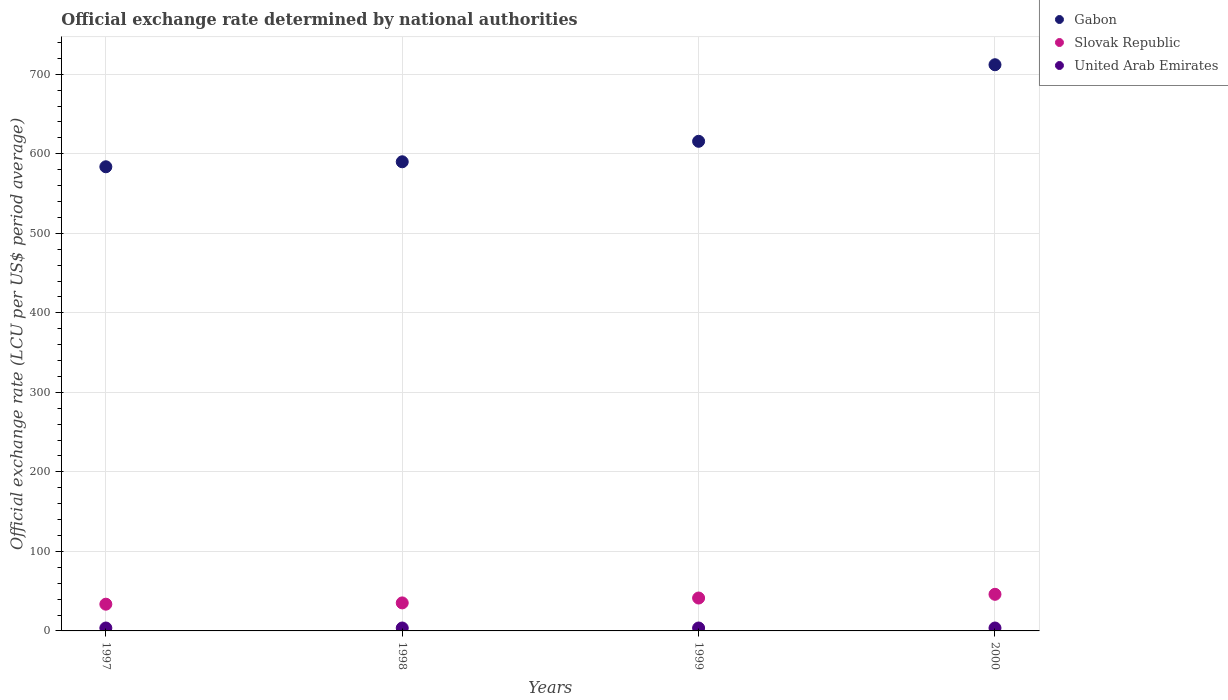How many different coloured dotlines are there?
Make the answer very short. 3. What is the official exchange rate in Slovak Republic in 1997?
Keep it short and to the point. 33.62. Across all years, what is the maximum official exchange rate in United Arab Emirates?
Your answer should be compact. 3.67. Across all years, what is the minimum official exchange rate in United Arab Emirates?
Your answer should be compact. 3.67. What is the total official exchange rate in Gabon in the graph?
Make the answer very short. 2501.3. What is the difference between the official exchange rate in Gabon in 1997 and that in 2000?
Provide a succinct answer. -128.31. What is the difference between the official exchange rate in United Arab Emirates in 1998 and the official exchange rate in Slovak Republic in 1997?
Your response must be concise. -29.94. What is the average official exchange rate in United Arab Emirates per year?
Ensure brevity in your answer.  3.67. In the year 2000, what is the difference between the official exchange rate in Gabon and official exchange rate in United Arab Emirates?
Give a very brief answer. 708.3. In how many years, is the official exchange rate in Gabon greater than 520 LCU?
Keep it short and to the point. 4. What is the ratio of the official exchange rate in Slovak Republic in 1997 to that in 1998?
Provide a short and direct response. 0.95. Is the official exchange rate in United Arab Emirates in 1997 less than that in 1999?
Provide a succinct answer. Yes. What is the difference between the highest and the lowest official exchange rate in Gabon?
Give a very brief answer. 128.31. Is it the case that in every year, the sum of the official exchange rate in United Arab Emirates and official exchange rate in Gabon  is greater than the official exchange rate in Slovak Republic?
Offer a terse response. Yes. Does the official exchange rate in Gabon monotonically increase over the years?
Provide a short and direct response. Yes. What is the difference between two consecutive major ticks on the Y-axis?
Offer a terse response. 100. Are the values on the major ticks of Y-axis written in scientific E-notation?
Keep it short and to the point. No. Does the graph contain grids?
Give a very brief answer. Yes. How many legend labels are there?
Provide a short and direct response. 3. What is the title of the graph?
Keep it short and to the point. Official exchange rate determined by national authorities. What is the label or title of the Y-axis?
Offer a terse response. Official exchange rate (LCU per US$ period average). What is the Official exchange rate (LCU per US$ period average) of Gabon in 1997?
Keep it short and to the point. 583.67. What is the Official exchange rate (LCU per US$ period average) of Slovak Republic in 1997?
Ensure brevity in your answer.  33.62. What is the Official exchange rate (LCU per US$ period average) in United Arab Emirates in 1997?
Keep it short and to the point. 3.67. What is the Official exchange rate (LCU per US$ period average) of Gabon in 1998?
Offer a very short reply. 589.95. What is the Official exchange rate (LCU per US$ period average) of Slovak Republic in 1998?
Offer a terse response. 35.23. What is the Official exchange rate (LCU per US$ period average) in United Arab Emirates in 1998?
Your answer should be very brief. 3.67. What is the Official exchange rate (LCU per US$ period average) in Gabon in 1999?
Make the answer very short. 615.7. What is the Official exchange rate (LCU per US$ period average) of Slovak Republic in 1999?
Keep it short and to the point. 41.36. What is the Official exchange rate (LCU per US$ period average) of United Arab Emirates in 1999?
Offer a terse response. 3.67. What is the Official exchange rate (LCU per US$ period average) in Gabon in 2000?
Your answer should be very brief. 711.98. What is the Official exchange rate (LCU per US$ period average) in Slovak Republic in 2000?
Provide a short and direct response. 46.04. What is the Official exchange rate (LCU per US$ period average) of United Arab Emirates in 2000?
Keep it short and to the point. 3.67. Across all years, what is the maximum Official exchange rate (LCU per US$ period average) of Gabon?
Your answer should be very brief. 711.98. Across all years, what is the maximum Official exchange rate (LCU per US$ period average) of Slovak Republic?
Provide a short and direct response. 46.04. Across all years, what is the maximum Official exchange rate (LCU per US$ period average) of United Arab Emirates?
Keep it short and to the point. 3.67. Across all years, what is the minimum Official exchange rate (LCU per US$ period average) in Gabon?
Make the answer very short. 583.67. Across all years, what is the minimum Official exchange rate (LCU per US$ period average) of Slovak Republic?
Ensure brevity in your answer.  33.62. Across all years, what is the minimum Official exchange rate (LCU per US$ period average) of United Arab Emirates?
Your answer should be compact. 3.67. What is the total Official exchange rate (LCU per US$ period average) of Gabon in the graph?
Provide a succinct answer. 2501.3. What is the total Official exchange rate (LCU per US$ period average) of Slovak Republic in the graph?
Give a very brief answer. 156.25. What is the total Official exchange rate (LCU per US$ period average) of United Arab Emirates in the graph?
Give a very brief answer. 14.69. What is the difference between the Official exchange rate (LCU per US$ period average) in Gabon in 1997 and that in 1998?
Offer a very short reply. -6.28. What is the difference between the Official exchange rate (LCU per US$ period average) of Slovak Republic in 1997 and that in 1998?
Offer a very short reply. -1.62. What is the difference between the Official exchange rate (LCU per US$ period average) of United Arab Emirates in 1997 and that in 1998?
Provide a succinct answer. -0. What is the difference between the Official exchange rate (LCU per US$ period average) in Gabon in 1997 and that in 1999?
Provide a succinct answer. -32.03. What is the difference between the Official exchange rate (LCU per US$ period average) of Slovak Republic in 1997 and that in 1999?
Your answer should be very brief. -7.75. What is the difference between the Official exchange rate (LCU per US$ period average) in United Arab Emirates in 1997 and that in 1999?
Give a very brief answer. -0. What is the difference between the Official exchange rate (LCU per US$ period average) in Gabon in 1997 and that in 2000?
Make the answer very short. -128.31. What is the difference between the Official exchange rate (LCU per US$ period average) of Slovak Republic in 1997 and that in 2000?
Provide a short and direct response. -12.42. What is the difference between the Official exchange rate (LCU per US$ period average) of United Arab Emirates in 1997 and that in 2000?
Make the answer very short. -0. What is the difference between the Official exchange rate (LCU per US$ period average) of Gabon in 1998 and that in 1999?
Give a very brief answer. -25.75. What is the difference between the Official exchange rate (LCU per US$ period average) of Slovak Republic in 1998 and that in 1999?
Keep it short and to the point. -6.13. What is the difference between the Official exchange rate (LCU per US$ period average) of Gabon in 1998 and that in 2000?
Give a very brief answer. -122.02. What is the difference between the Official exchange rate (LCU per US$ period average) of Slovak Republic in 1998 and that in 2000?
Provide a succinct answer. -10.8. What is the difference between the Official exchange rate (LCU per US$ period average) in United Arab Emirates in 1998 and that in 2000?
Provide a succinct answer. 0. What is the difference between the Official exchange rate (LCU per US$ period average) of Gabon in 1999 and that in 2000?
Provide a succinct answer. -96.28. What is the difference between the Official exchange rate (LCU per US$ period average) in Slovak Republic in 1999 and that in 2000?
Your response must be concise. -4.67. What is the difference between the Official exchange rate (LCU per US$ period average) of United Arab Emirates in 1999 and that in 2000?
Ensure brevity in your answer.  0. What is the difference between the Official exchange rate (LCU per US$ period average) of Gabon in 1997 and the Official exchange rate (LCU per US$ period average) of Slovak Republic in 1998?
Offer a terse response. 548.44. What is the difference between the Official exchange rate (LCU per US$ period average) of Gabon in 1997 and the Official exchange rate (LCU per US$ period average) of United Arab Emirates in 1998?
Your response must be concise. 580. What is the difference between the Official exchange rate (LCU per US$ period average) of Slovak Republic in 1997 and the Official exchange rate (LCU per US$ period average) of United Arab Emirates in 1998?
Provide a succinct answer. 29.94. What is the difference between the Official exchange rate (LCU per US$ period average) of Gabon in 1997 and the Official exchange rate (LCU per US$ period average) of Slovak Republic in 1999?
Provide a succinct answer. 542.31. What is the difference between the Official exchange rate (LCU per US$ period average) in Gabon in 1997 and the Official exchange rate (LCU per US$ period average) in United Arab Emirates in 1999?
Your answer should be very brief. 580. What is the difference between the Official exchange rate (LCU per US$ period average) of Slovak Republic in 1997 and the Official exchange rate (LCU per US$ period average) of United Arab Emirates in 1999?
Provide a short and direct response. 29.94. What is the difference between the Official exchange rate (LCU per US$ period average) of Gabon in 1997 and the Official exchange rate (LCU per US$ period average) of Slovak Republic in 2000?
Give a very brief answer. 537.63. What is the difference between the Official exchange rate (LCU per US$ period average) in Gabon in 1997 and the Official exchange rate (LCU per US$ period average) in United Arab Emirates in 2000?
Keep it short and to the point. 580. What is the difference between the Official exchange rate (LCU per US$ period average) of Slovak Republic in 1997 and the Official exchange rate (LCU per US$ period average) of United Arab Emirates in 2000?
Your answer should be very brief. 29.94. What is the difference between the Official exchange rate (LCU per US$ period average) in Gabon in 1998 and the Official exchange rate (LCU per US$ period average) in Slovak Republic in 1999?
Offer a terse response. 548.59. What is the difference between the Official exchange rate (LCU per US$ period average) of Gabon in 1998 and the Official exchange rate (LCU per US$ period average) of United Arab Emirates in 1999?
Provide a succinct answer. 586.28. What is the difference between the Official exchange rate (LCU per US$ period average) in Slovak Republic in 1998 and the Official exchange rate (LCU per US$ period average) in United Arab Emirates in 1999?
Provide a short and direct response. 31.56. What is the difference between the Official exchange rate (LCU per US$ period average) in Gabon in 1998 and the Official exchange rate (LCU per US$ period average) in Slovak Republic in 2000?
Provide a succinct answer. 543.92. What is the difference between the Official exchange rate (LCU per US$ period average) in Gabon in 1998 and the Official exchange rate (LCU per US$ period average) in United Arab Emirates in 2000?
Keep it short and to the point. 586.28. What is the difference between the Official exchange rate (LCU per US$ period average) of Slovak Republic in 1998 and the Official exchange rate (LCU per US$ period average) of United Arab Emirates in 2000?
Your answer should be very brief. 31.56. What is the difference between the Official exchange rate (LCU per US$ period average) of Gabon in 1999 and the Official exchange rate (LCU per US$ period average) of Slovak Republic in 2000?
Your answer should be compact. 569.66. What is the difference between the Official exchange rate (LCU per US$ period average) of Gabon in 1999 and the Official exchange rate (LCU per US$ period average) of United Arab Emirates in 2000?
Offer a terse response. 612.03. What is the difference between the Official exchange rate (LCU per US$ period average) of Slovak Republic in 1999 and the Official exchange rate (LCU per US$ period average) of United Arab Emirates in 2000?
Offer a very short reply. 37.69. What is the average Official exchange rate (LCU per US$ period average) in Gabon per year?
Provide a succinct answer. 625.32. What is the average Official exchange rate (LCU per US$ period average) of Slovak Republic per year?
Offer a terse response. 39.06. What is the average Official exchange rate (LCU per US$ period average) of United Arab Emirates per year?
Provide a short and direct response. 3.67. In the year 1997, what is the difference between the Official exchange rate (LCU per US$ period average) in Gabon and Official exchange rate (LCU per US$ period average) in Slovak Republic?
Give a very brief answer. 550.05. In the year 1997, what is the difference between the Official exchange rate (LCU per US$ period average) in Gabon and Official exchange rate (LCU per US$ period average) in United Arab Emirates?
Give a very brief answer. 580. In the year 1997, what is the difference between the Official exchange rate (LCU per US$ period average) in Slovak Republic and Official exchange rate (LCU per US$ period average) in United Arab Emirates?
Provide a succinct answer. 29.95. In the year 1998, what is the difference between the Official exchange rate (LCU per US$ period average) in Gabon and Official exchange rate (LCU per US$ period average) in Slovak Republic?
Make the answer very short. 554.72. In the year 1998, what is the difference between the Official exchange rate (LCU per US$ period average) in Gabon and Official exchange rate (LCU per US$ period average) in United Arab Emirates?
Keep it short and to the point. 586.28. In the year 1998, what is the difference between the Official exchange rate (LCU per US$ period average) of Slovak Republic and Official exchange rate (LCU per US$ period average) of United Arab Emirates?
Provide a succinct answer. 31.56. In the year 1999, what is the difference between the Official exchange rate (LCU per US$ period average) in Gabon and Official exchange rate (LCU per US$ period average) in Slovak Republic?
Ensure brevity in your answer.  574.34. In the year 1999, what is the difference between the Official exchange rate (LCU per US$ period average) of Gabon and Official exchange rate (LCU per US$ period average) of United Arab Emirates?
Your response must be concise. 612.03. In the year 1999, what is the difference between the Official exchange rate (LCU per US$ period average) in Slovak Republic and Official exchange rate (LCU per US$ period average) in United Arab Emirates?
Your answer should be compact. 37.69. In the year 2000, what is the difference between the Official exchange rate (LCU per US$ period average) of Gabon and Official exchange rate (LCU per US$ period average) of Slovak Republic?
Make the answer very short. 665.94. In the year 2000, what is the difference between the Official exchange rate (LCU per US$ period average) in Gabon and Official exchange rate (LCU per US$ period average) in United Arab Emirates?
Your response must be concise. 708.3. In the year 2000, what is the difference between the Official exchange rate (LCU per US$ period average) in Slovak Republic and Official exchange rate (LCU per US$ period average) in United Arab Emirates?
Offer a very short reply. 42.36. What is the ratio of the Official exchange rate (LCU per US$ period average) in Gabon in 1997 to that in 1998?
Your response must be concise. 0.99. What is the ratio of the Official exchange rate (LCU per US$ period average) of Slovak Republic in 1997 to that in 1998?
Your answer should be compact. 0.95. What is the ratio of the Official exchange rate (LCU per US$ period average) in Gabon in 1997 to that in 1999?
Your response must be concise. 0.95. What is the ratio of the Official exchange rate (LCU per US$ period average) of Slovak Republic in 1997 to that in 1999?
Your answer should be compact. 0.81. What is the ratio of the Official exchange rate (LCU per US$ period average) in United Arab Emirates in 1997 to that in 1999?
Your response must be concise. 1. What is the ratio of the Official exchange rate (LCU per US$ period average) in Gabon in 1997 to that in 2000?
Ensure brevity in your answer.  0.82. What is the ratio of the Official exchange rate (LCU per US$ period average) in Slovak Republic in 1997 to that in 2000?
Your answer should be very brief. 0.73. What is the ratio of the Official exchange rate (LCU per US$ period average) of Gabon in 1998 to that in 1999?
Provide a short and direct response. 0.96. What is the ratio of the Official exchange rate (LCU per US$ period average) of Slovak Republic in 1998 to that in 1999?
Keep it short and to the point. 0.85. What is the ratio of the Official exchange rate (LCU per US$ period average) in Gabon in 1998 to that in 2000?
Provide a succinct answer. 0.83. What is the ratio of the Official exchange rate (LCU per US$ period average) in Slovak Republic in 1998 to that in 2000?
Offer a terse response. 0.77. What is the ratio of the Official exchange rate (LCU per US$ period average) of United Arab Emirates in 1998 to that in 2000?
Provide a short and direct response. 1. What is the ratio of the Official exchange rate (LCU per US$ period average) of Gabon in 1999 to that in 2000?
Your answer should be very brief. 0.86. What is the ratio of the Official exchange rate (LCU per US$ period average) of Slovak Republic in 1999 to that in 2000?
Provide a short and direct response. 0.9. What is the difference between the highest and the second highest Official exchange rate (LCU per US$ period average) of Gabon?
Your answer should be very brief. 96.28. What is the difference between the highest and the second highest Official exchange rate (LCU per US$ period average) in Slovak Republic?
Keep it short and to the point. 4.67. What is the difference between the highest and the second highest Official exchange rate (LCU per US$ period average) in United Arab Emirates?
Your answer should be very brief. 0. What is the difference between the highest and the lowest Official exchange rate (LCU per US$ period average) of Gabon?
Provide a short and direct response. 128.31. What is the difference between the highest and the lowest Official exchange rate (LCU per US$ period average) of Slovak Republic?
Provide a short and direct response. 12.42. What is the difference between the highest and the lowest Official exchange rate (LCU per US$ period average) in United Arab Emirates?
Ensure brevity in your answer.  0. 